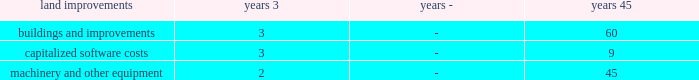Income and franchise tax provisions are allocable to contracts in process and , accordingly , are included in general and administrative expenses .
Deferred income taxes are recorded when revenues and expenses are recognized in different periods for financial statement purposes than for tax return purposes .
Deferred tax asset or liability account balances are calculated at the balance sheet date using current tax laws and rates in effect .
Determinations of the expected realizability of deferred tax assets and the need for any valuation allowances against these deferred tax assets were evaluated based upon the stand-alone tax attributes of the company , and valuation allowances of $ 21 million and $ 18 million were deemed necessary as of december 31 , 2012 and 2011 , respectively .
Uncertain tax positions meeting the more-likely-than-not recognition threshold , based on the merits of the position , are recognized in the financial statements .
We recognize the amount of tax benefit that is greater than 50% ( 50 % ) likely to be realized upon ultimate settlement with the related tax authority .
If a tax position does not meet the minimum statutory threshold to avoid payment of penalties , we recognize an expense for the amount of the penalty in the period the tax position is claimed or expected to be claimed in our tax return .
Penalties , if probable and reasonably estimable , are recognized as a component of income tax expense .
We also recognize accrued interest related to uncertain tax positions in income tax expense .
The timing and amount of accrued interest is determined by the applicable tax law associated with an underpayment of income taxes .
See note 11 : income taxes .
Under existing gaap , changes in accruals associated with uncertainties are recorded in earnings in the period they are determined .
Cash and cash equivalents - the carrying amounts of cash and cash equivalents approximate fair value due to the short-term nature of these items , having original maturity dates of 90 days or less .
Accounts receivable - accounts receivable include amounts billed and currently due from customers , amounts currently due but unbilled , certain estimated contract change amounts , claims or requests for equitable adjustment in negotiation that are probable of recovery , and amounts retained by the customer pending contract completion .
Inventoried costs - inventoried costs primarily relate to work in process under contracts that recognize revenues using labor dollars or units of delivery as the basis of the percentage-of-completion calculation .
These costs represent accumulated contract costs less cost of sales , as calculated using the percentage-of-completion method .
Accumulated contract costs include direct production costs , factory and engineering overhead , production tooling costs , and , for government contracts , allowable general and administrative expenses .
According to the provisions of the company's u.s .
Government contracts , the customer asserts title to , or a security interest in , inventories related to such contracts as a result of contract advances , performance-based payments , and progress payments .
In accordance with industry practice , inventoried costs are classified as a current asset and include amounts related to contracts having production cycles longer than one year .
Inventoried costs also include company owned raw materials , which are stated at the lower of cost or market , generally using the average cost method .
Property , plant , and equipment - depreciable properties owned by the company are recorded at cost and depreciated over the estimated useful lives of individual assets .
Costs incurred for computer software developed or obtained for internal use are capitalized and amortized over the expected useful life of the software , not to exceed nine years .
Leasehold improvements are amortized over the shorter of their useful lives or the term of the lease .
The remaining assets are depreciated using the straight-line method , with the following lives: .
The company evaluates the recoverability of its property , plant and equipment when there are changes in economic circumstances or business objectives that indicate the carrying value may not be recoverable .
The company's evaluations include estimated future cash flows , profitability and other factors in determining fair value .
As these assumptions and estimates may change over time , it may or may not be necessary to record impairment charges. .
Wha is the percentage change in the valuation allowance from 2011 to 2012? 
Computations: ((21 - 18) / 18)
Answer: 0.16667. 